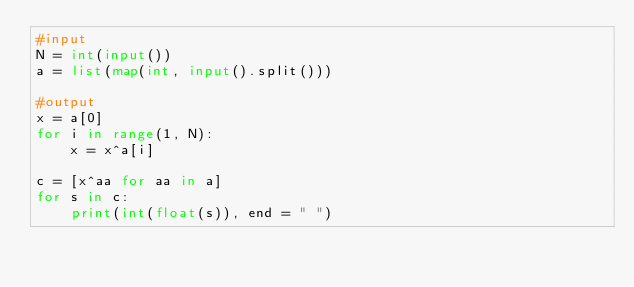<code> <loc_0><loc_0><loc_500><loc_500><_Python_>#input
N = int(input())
a = list(map(int, input().split()))

#output
x = a[0]
for i in range(1, N):
    x = x^a[i]

c = [x^aa for aa in a]
for s in c:
    print(int(float(s)), end = " ")</code> 